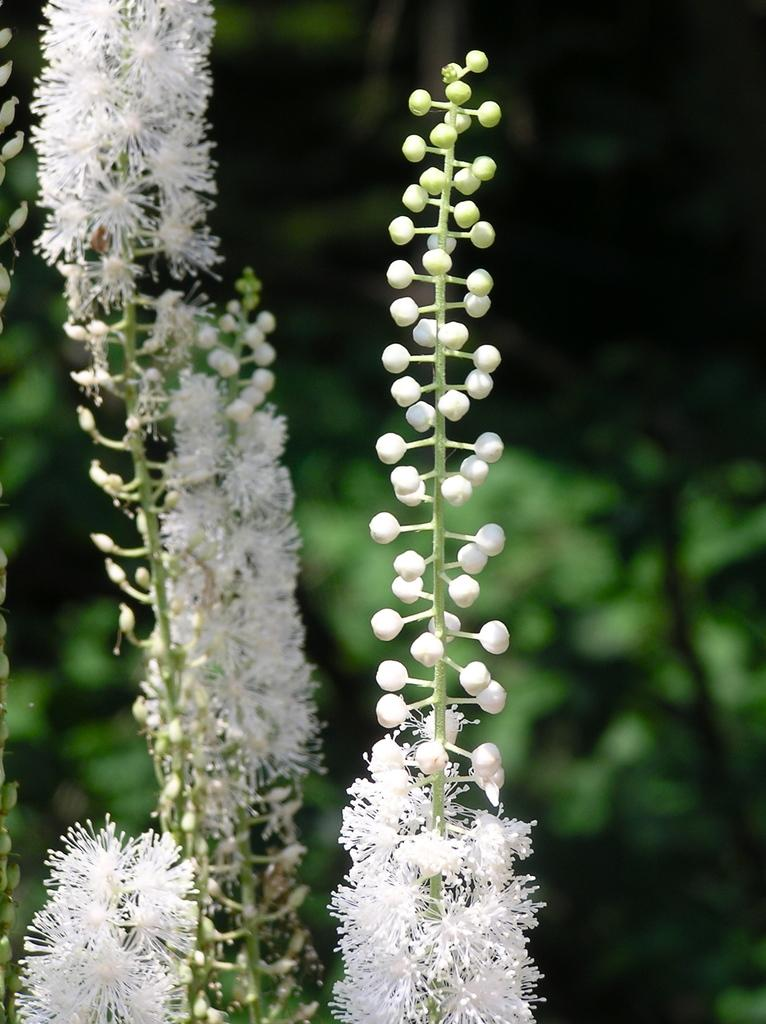What type of plants can be seen in the image? There are plants with flowers and plants with buds in the image. What stage of growth are the plants with buds in? The plants with buds are in the stage before the flowers bloom. What can be seen in the background of the image? The background of the image appears to be greenery, although it is blurred. Can you hear the plants crying in the image? There are no sounds in the image, and plants do not have the ability to cry. 